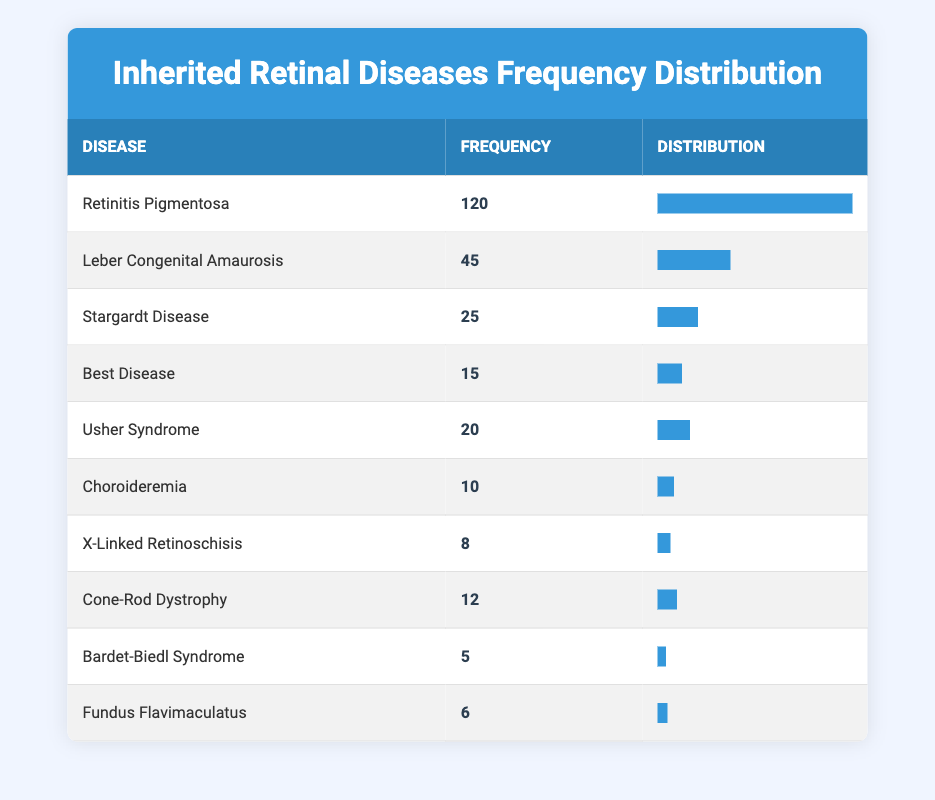What is the frequency of Retinitis Pigmentosa? The frequency of Retinitis Pigmentosa can be directly found in the table under the "Frequency" column, which shows a value of 120.
Answer: 120 How many cases of Leber Congenital Amaurosis are reported? Leber Congenital Amaurosis has a frequency of 45, as indicated in the corresponding row in the table.
Answer: 45 What is the total frequency of all listed inherited retinal diseases? To find the total frequency, we sum up all individual frequencies: (120 + 45 + 25 + 15 + 20 + 10 + 8 + 12 + 5 + 6) =  336.
Answer: 336 Which disease has the least frequency? By comparing all disease frequencies, Bardet-Biedl Syndrome has the lowest frequency at 5.
Answer: Bardet-Biedl Syndrome Is the frequency of Cone-Rod Dystrophy greater than that of Choroideremia? Comparing the frequencies, Cone-Rod Dystrophy has a frequency of 12 and Choroideremia has a frequency of 10; thus, Cone-Rod Dystrophy is greater.
Answer: Yes How does the frequency of Usher Syndrome compare to that of Best Disease? Usher Syndrome has a frequency of 20, while Best Disease has a frequency of 15. Since 20 is greater than 15, Usher Syndrome has a higher frequency.
Answer: Usher Syndrome has a higher frequency What percentage of the total frequency does Stargardt Disease represent? First, we find the frequency of Stargardt Disease which is 25. The total frequency is 336. To find the percentage, we calculate (25/336)*100 = 7.43%.
Answer: 7.43% Is the frequency of X-Linked Retinoschisis greater than 10? The frequency of X-Linked Retinoschisis is 8, which is less than 10. Thus, the statement is false.
Answer: No Which disease represents about 37.5% of the total cases? We compare the frequencies of the diseases. Leber Congenital Amaurosis has a frequency of 45. Calculating (45/336)*100 gives approximately 13.39%, thus confirming it does not represent 37.5%. Further verification shows that no other diseases represent that high percentage as well. Hence, none fits.
Answer: None 